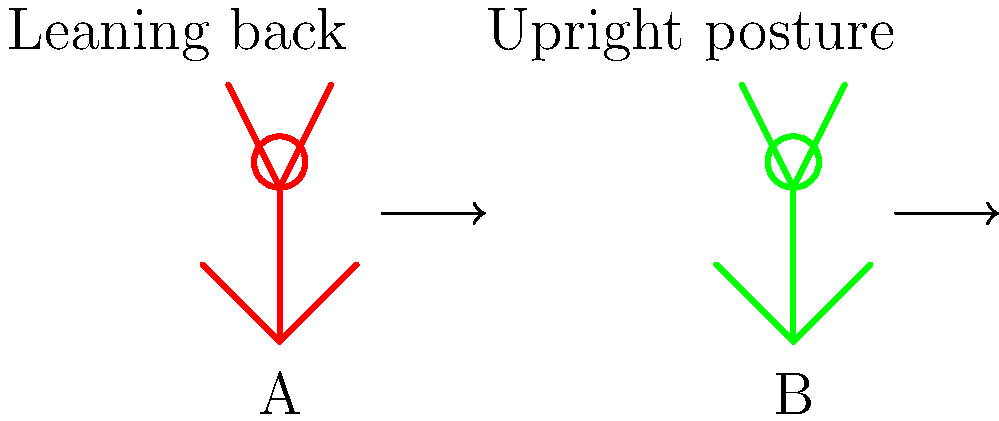Which stick figure demonstrates the correct running posture for efficient and injury-free jogging? To determine the correct running posture for efficient and injury-free jogging, let's analyze both stick figures:

1. Figure A:
   - Leaning backwards
   - Head tilted back
   - Arms at a wider angle

2. Figure B:
   - Upright posture
   - Head in line with the spine
   - Arms at a more compact angle

The correct running posture is demonstrated by Figure B for the following reasons:

1. Upright posture: An upright posture allows for better breathing and reduces strain on the back muscles. It also helps maintain proper alignment of the spine, hips, and legs.

2. Head position: Keeping the head in line with the spine reduces neck strain and promotes better overall body alignment.

3. Arm position: Compact arm positioning helps maintain balance and reduces energy expenditure during the run.

4. Forward lean: While not exaggerated in the figure, a slight forward lean from the ankles (not the waist) can help with momentum and reduce the impact on joints.

5. Midfoot strike: Although not visible in the stick figures, proper running form typically involves landing on the midfoot rather than the heel, which Figure B's posture would facilitate better than Figure A's backward lean.

Figure A's posture, with its backward lean, would likely lead to:
- Increased impact on the heels
- Reduced running efficiency
- Higher risk of lower back pain
- Potential breathing difficulties

Therefore, Figure B demonstrates the correct running posture for efficient and injury-free jogging.
Answer: Figure B 